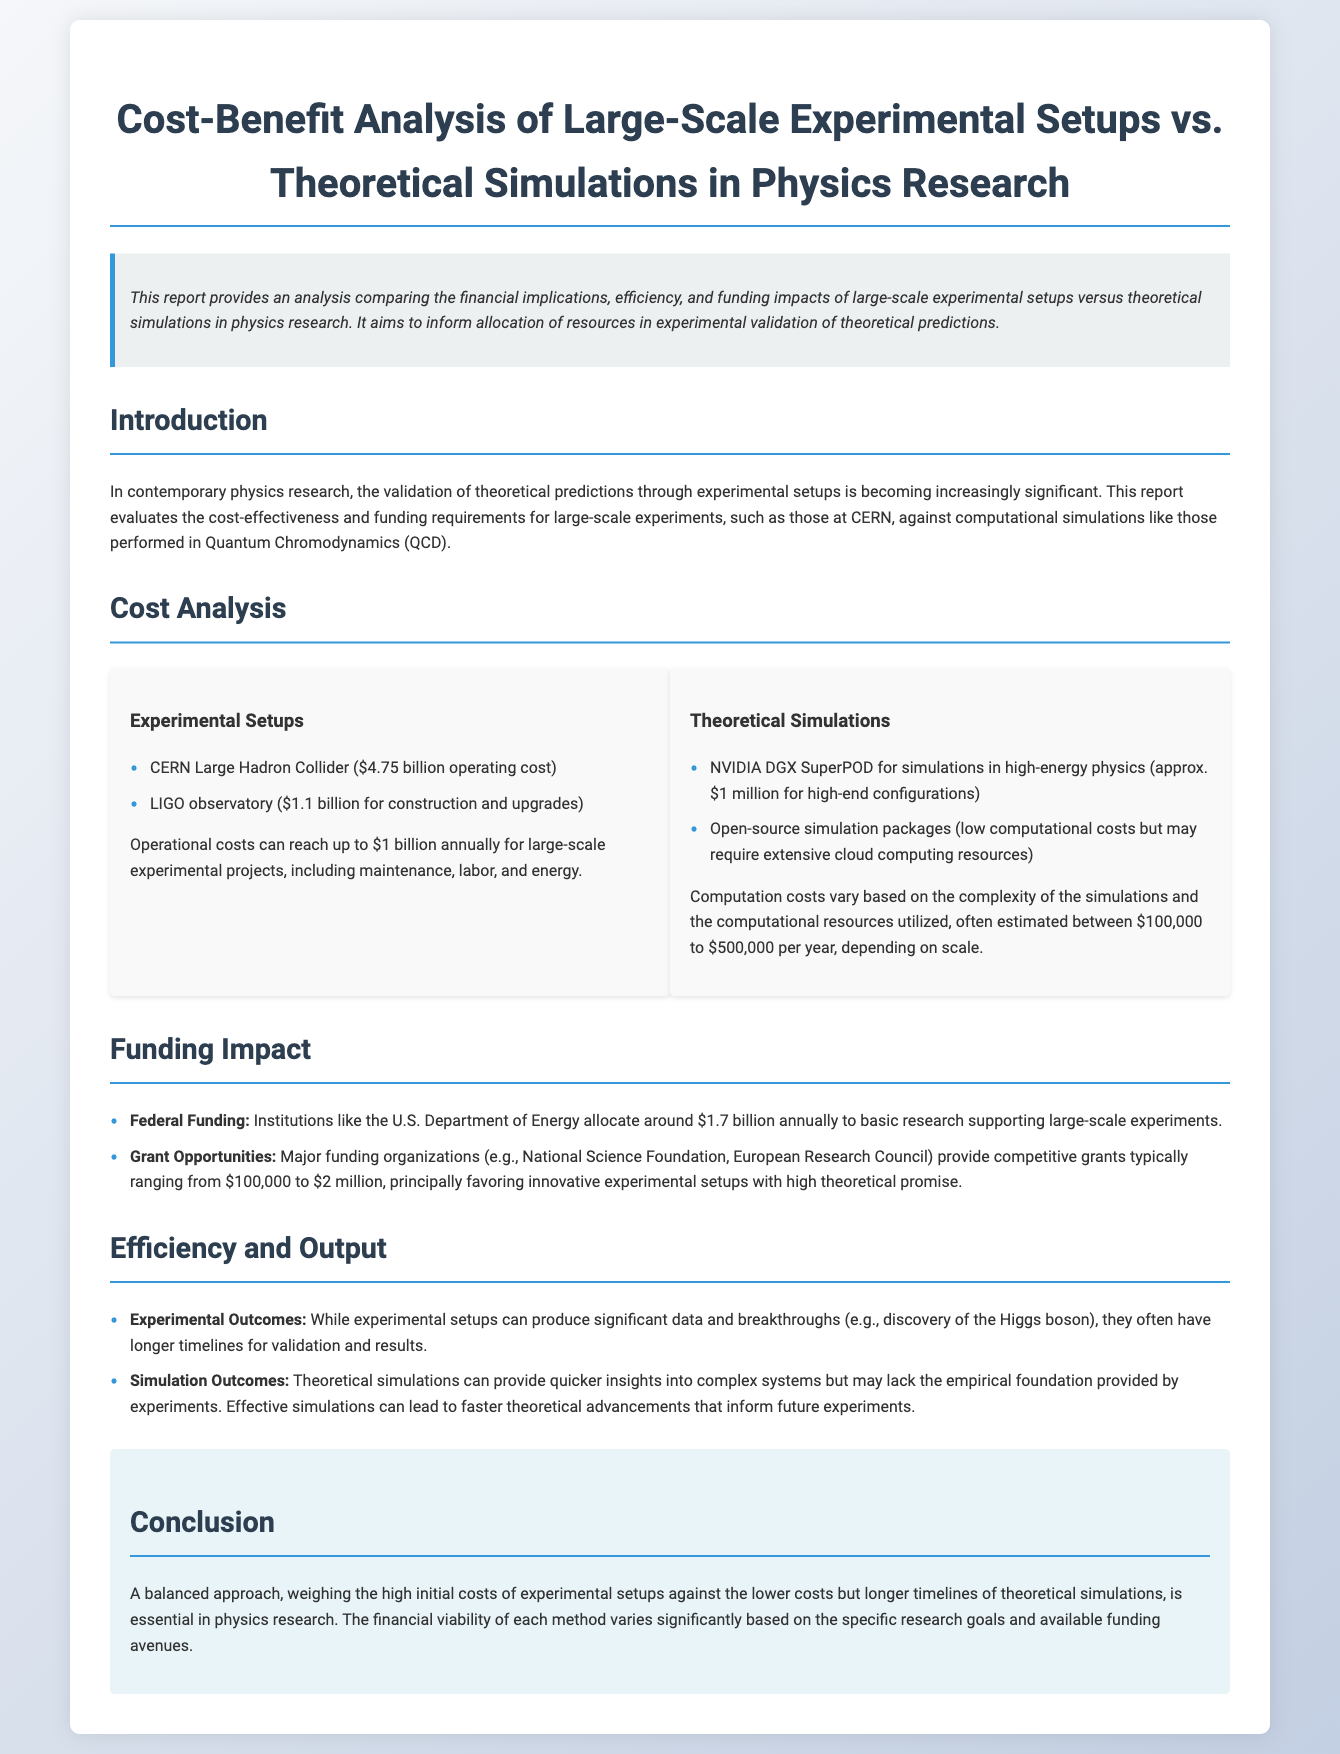what is the operating cost of the CERN Large Hadron Collider? The document states that the operating cost of the CERN Large Hadron Collider is $4.75 billion.
Answer: $4.75 billion what is the construction cost of the LIGO observatory? The document indicates that the construction and upgrades for the LIGO observatory totaled $1.1 billion.
Answer: $1.1 billion how much federal funding is allocated annually to basic research by the U.S. Department of Energy? According to the document, the U.S. Department of Energy allocates around $1.7 billion annually to basic research.
Answer: $1.7 billion what is the estimated annual computation cost for theoretical simulations? The document estimates the annual computation costs for theoretical simulations to be between $100,000 to $500,000.
Answer: $100,000 to $500,000 which major funding organization provides competitive grants for experimental setups? The document mentions the National Science Foundation as a major funding organization that provides competitive grants.
Answer: National Science Foundation compare the timelines for validation and results between experimental setups and theoretical simulations. The document notes that experimental setups often have longer timelines for validation and results compared to theoretical simulations, which can provide quicker insights.
Answer: Longer for experimental setups what is suggested as necessary in physics research regarding experimental and theoretical methods? The document suggests that a balanced approach weighing the costs and timelines of both methods is essential in physics research.
Answer: A balanced approach what is a primary benefit of theoretical simulations mentioned in the document? The document states that theoretical simulations can provide quicker insights into complex systems.
Answer: Quicker insights 